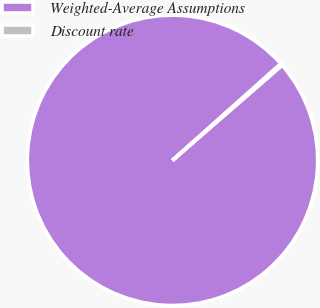Convert chart to OTSL. <chart><loc_0><loc_0><loc_500><loc_500><pie_chart><fcel>Weighted-Average Assumptions<fcel>Discount rate<nl><fcel>99.79%<fcel>0.21%<nl></chart> 